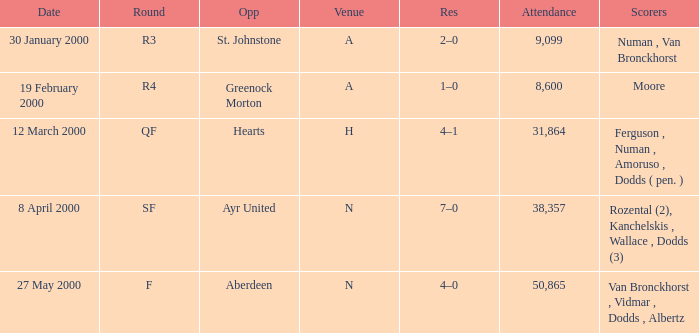Who was on 12 March 2000? Ferguson , Numan , Amoruso , Dodds ( pen. ). 